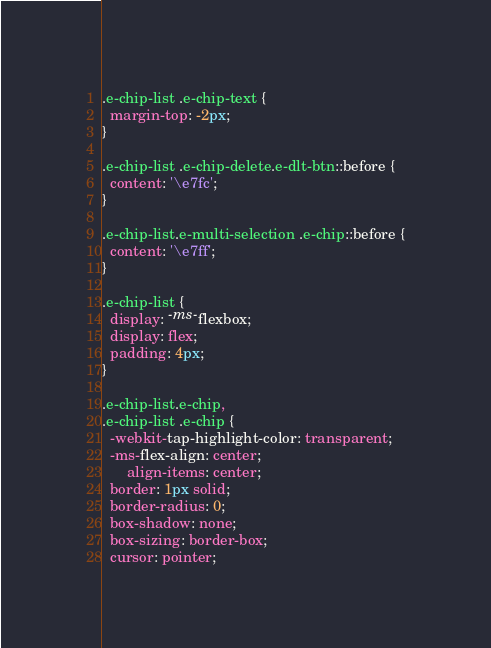Convert code to text. <code><loc_0><loc_0><loc_500><loc_500><_CSS_>.e-chip-list .e-chip-text {
  margin-top: -2px;
}

.e-chip-list .e-chip-delete.e-dlt-btn::before {
  content: '\e7fc';
}

.e-chip-list.e-multi-selection .e-chip::before {
  content: '\e7ff';
}

.e-chip-list {
  display: -ms-flexbox;
  display: flex;
  padding: 4px;
}

.e-chip-list.e-chip,
.e-chip-list .e-chip {
  -webkit-tap-highlight-color: transparent;
  -ms-flex-align: center;
      align-items: center;
  border: 1px solid;
  border-radius: 0;
  box-shadow: none;
  box-sizing: border-box;
  cursor: pointer;</code> 